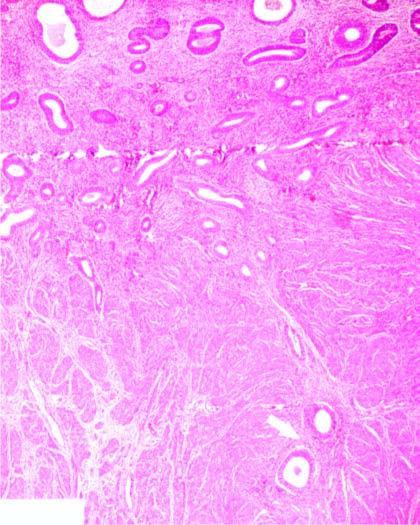re inflammatory changes present deep inside the myometrium?
Answer the question using a single word or phrase. No 